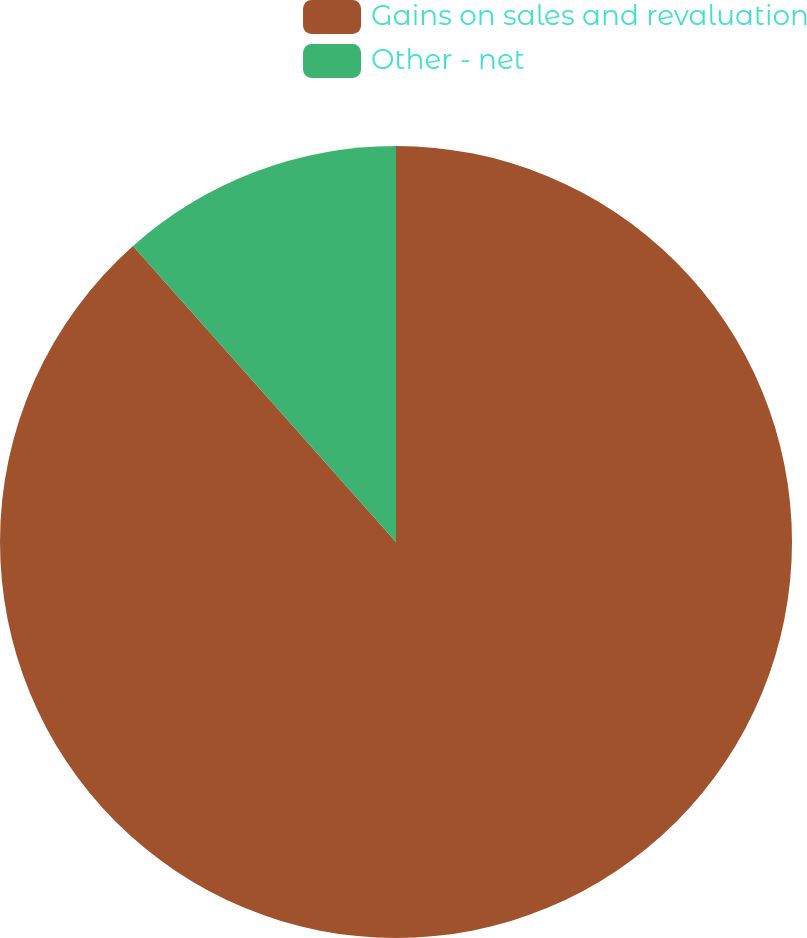Convert chart. <chart><loc_0><loc_0><loc_500><loc_500><pie_chart><fcel>Gains on sales and revaluation<fcel>Other - net<nl><fcel>88.44%<fcel>11.56%<nl></chart> 